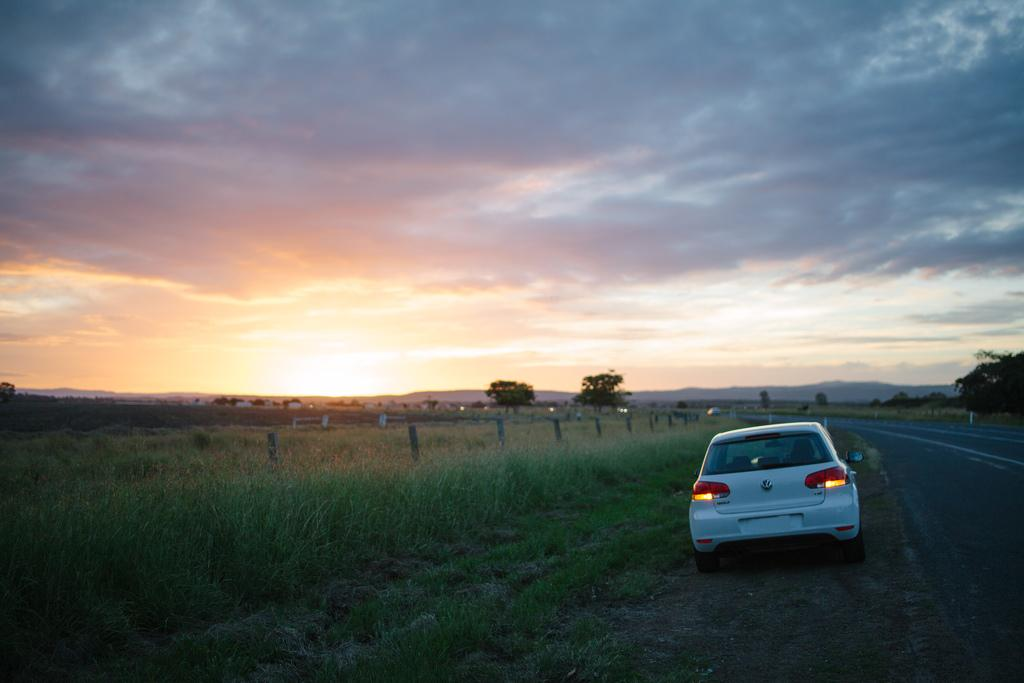What type of vehicle is in the image? There is a white car in the image. Where is the car located in relation to the road? The car is beside the road. What can be seen on the side of the road? There is grass on the side of the road. What is near the grass? There is fencing near the grass. What is visible in the background of the image? There are trees and a cloudy sky in the background. What specific feature of the sky is visible? There is a sunset visible in the sky. What type of current is flowing through the sheet in the image? There is no sheet or current present in the image. 